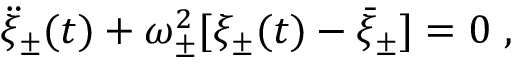Convert formula to latex. <formula><loc_0><loc_0><loc_500><loc_500>\ddot { \xi } _ { \pm } ( t ) + \omega _ { \pm } ^ { 2 } [ \xi _ { \pm } ( t ) - \bar { \xi } _ { \pm } ] = 0 \ ,</formula> 